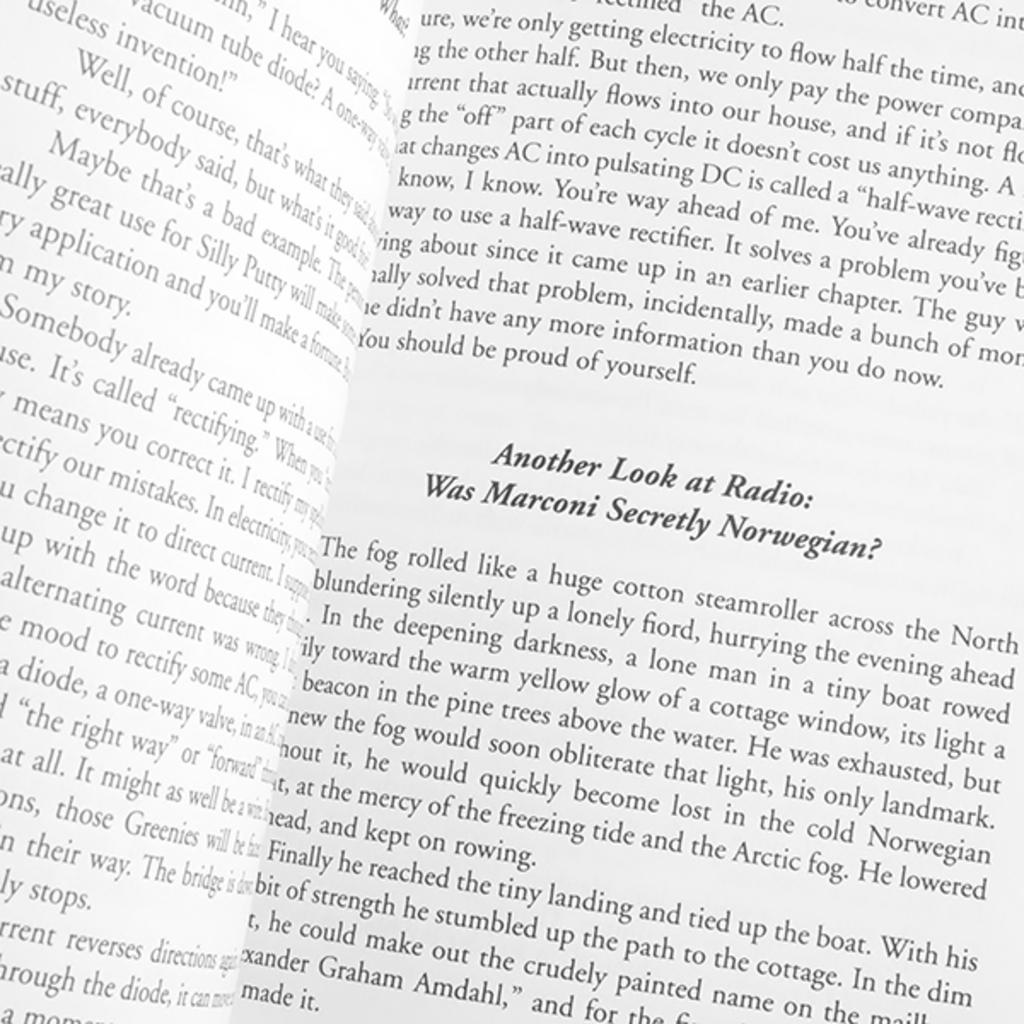<image>
Render a clear and concise summary of the photo. A written text asks if Marconi was secretly Norwegian. 